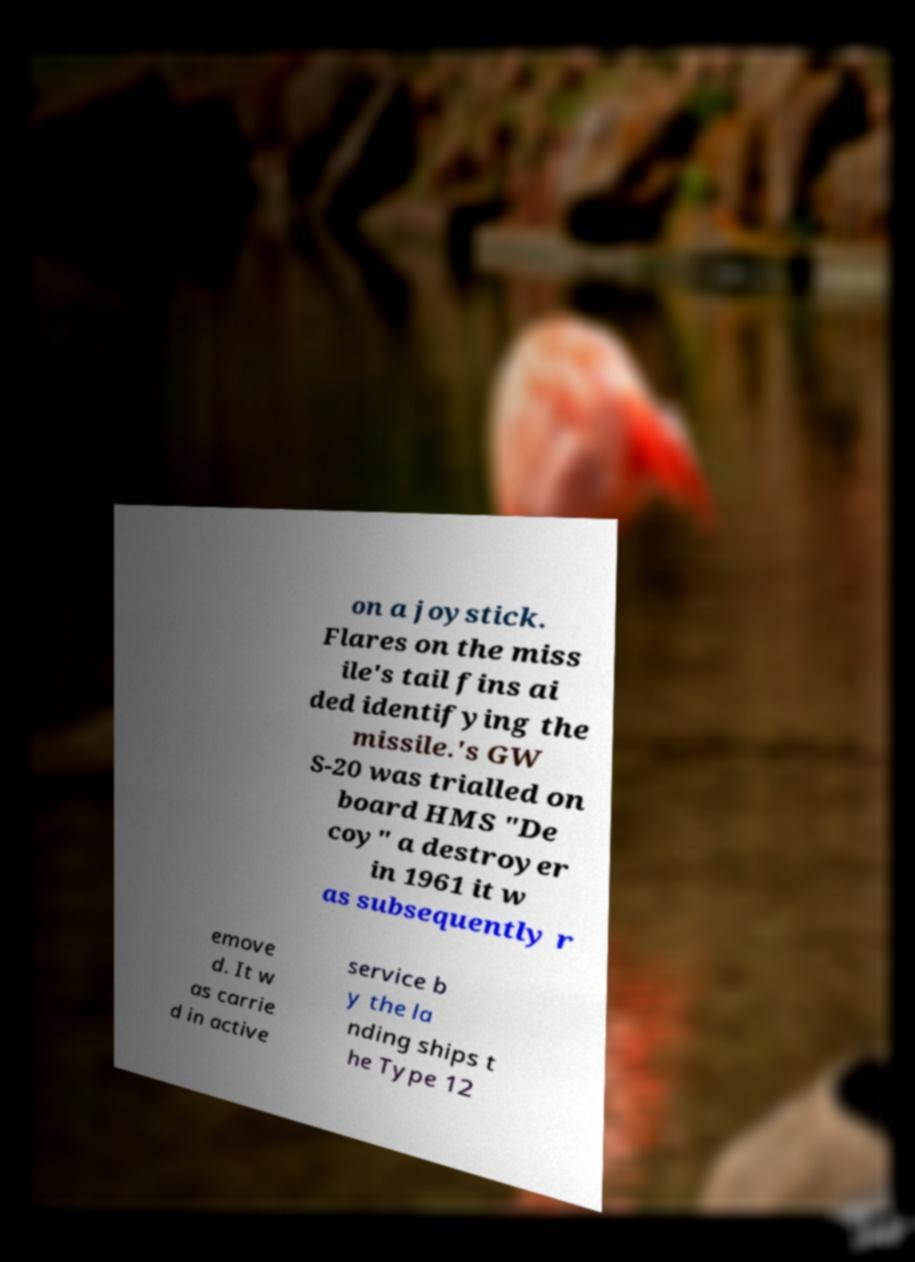Could you assist in decoding the text presented in this image and type it out clearly? on a joystick. Flares on the miss ile's tail fins ai ded identifying the missile.'s GW S-20 was trialled on board HMS "De coy" a destroyer in 1961 it w as subsequently r emove d. It w as carrie d in active service b y the la nding ships t he Type 12 